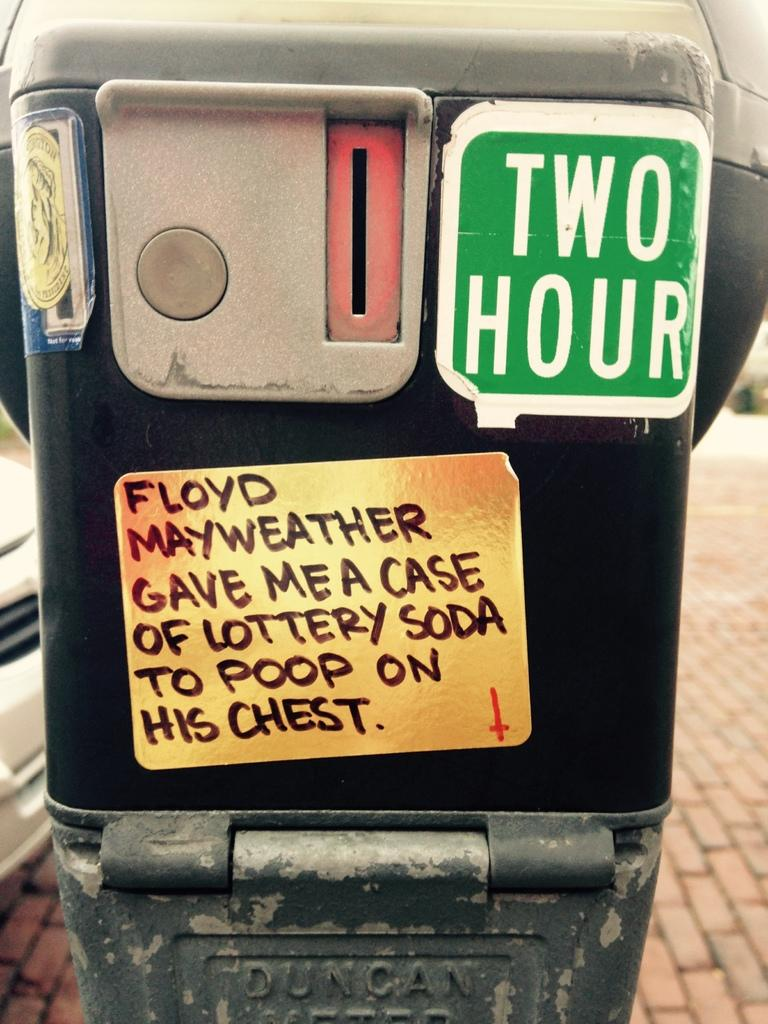<image>
Provide a brief description of the given image. A two hour parking meter on which someone has placed a sticker stating "Floyd Mayweather gave me a case of lottery soda to poop on his chest". 